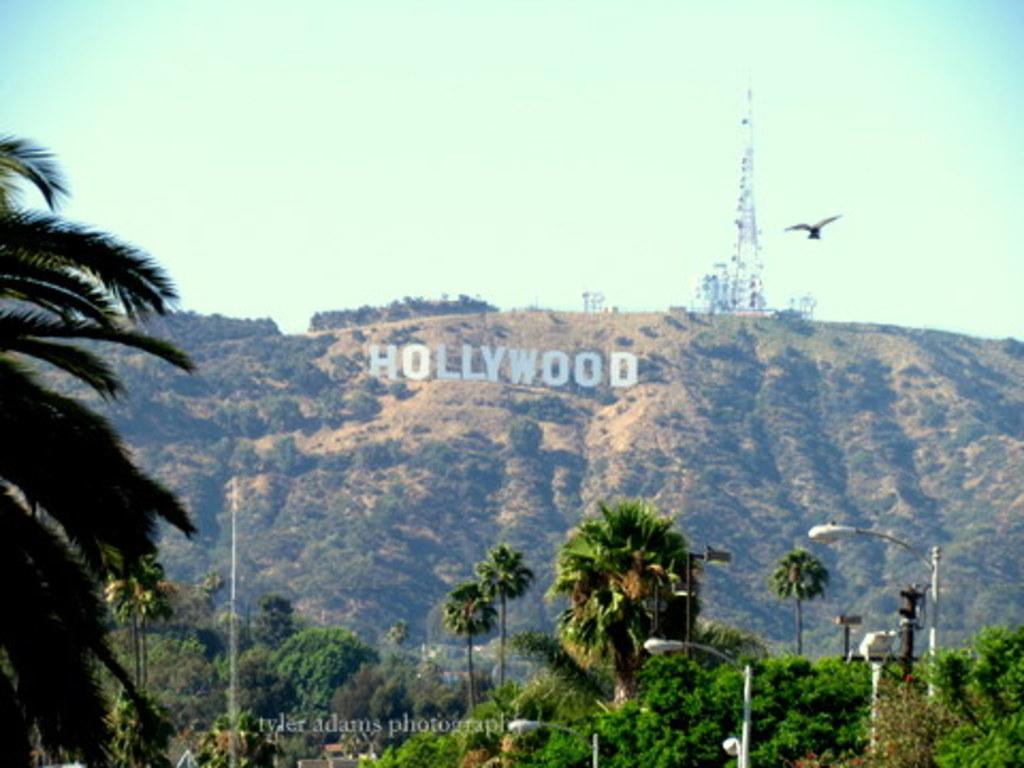Please provide a concise description of this image. In the background we can see the sky, tower and few objects. In this picture we can see the thicket. We can see a bird is flying. At the bottom portion of the picture we can see the lights, poles, trees and watermark. 